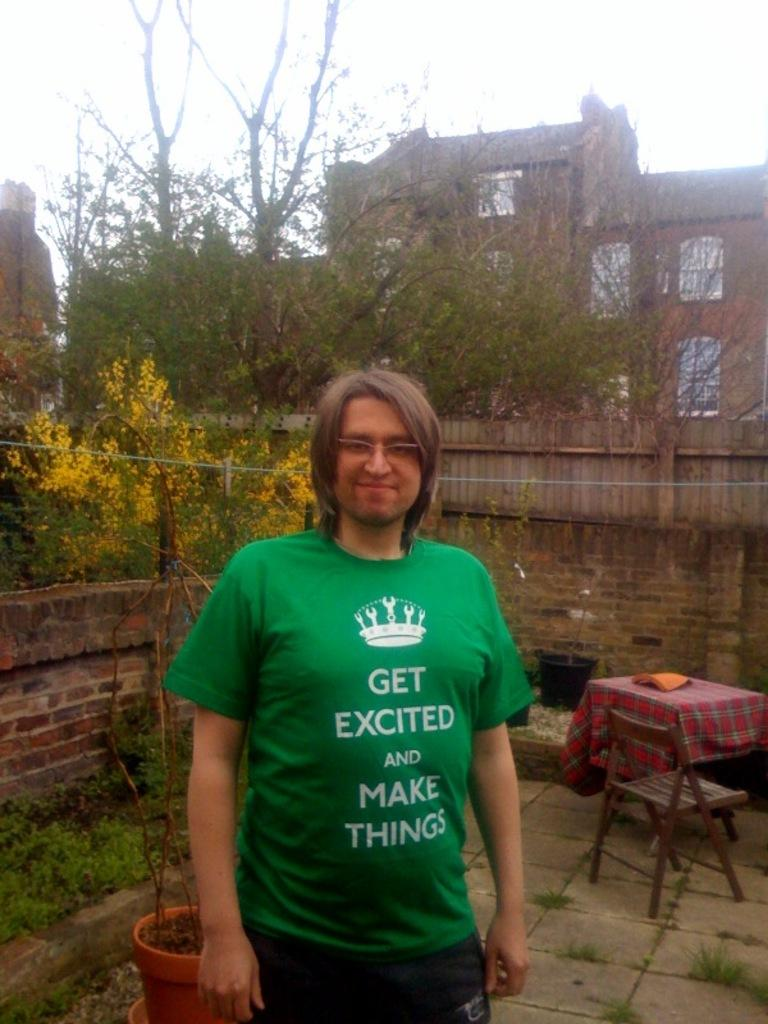Who is present in the image? There is a man in the image. What is the man's facial expression? The man is smiling. What can be seen in the distance in the image? There are houses visible in the background of the image. What type of vegetation is present in the image? There are plants in the image. What piece of furniture is visible in the image? There is a table in the image. What type of bit is the man using to eat the cabbage in the image? There is no cabbage or bit present in the image. What type of produce is the man holding in the image? The image does not show the man holding any produce. 